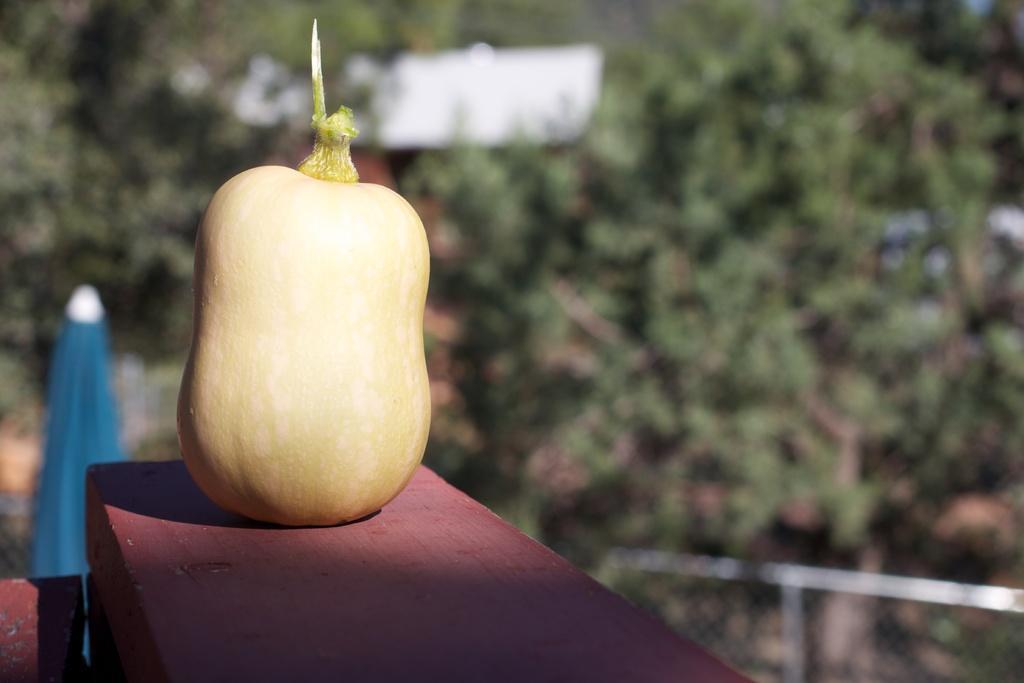How would you summarize this image in a sentence or two? This picture is clicked outside. On the left there is an object placed on a red color table. In the background we can see the trees, plants, net, metal rods and a blue color object seems to be an umbrella. 